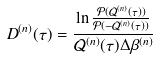Convert formula to latex. <formula><loc_0><loc_0><loc_500><loc_500>D ^ { ( n ) } ( \tau ) = \frac { \ln { \frac { \mathcal { P } ( \mathcal { Q } ^ { ( n ) } ( \tau ) ) } { \mathcal { P } ( - \mathcal { Q } ^ { ( n ) } ( \tau ) ) } } } { \mathcal { Q } ^ { ( n ) } ( \tau ) \Delta \beta ^ { ( n ) } }</formula> 